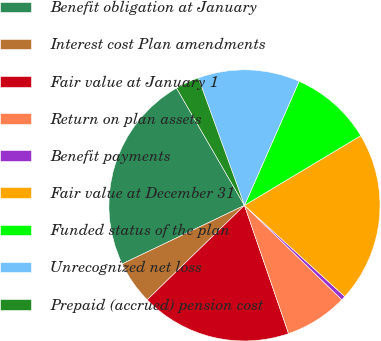Convert chart. <chart><loc_0><loc_0><loc_500><loc_500><pie_chart><fcel>Benefit obligation at January<fcel>Interest cost Plan amendments<fcel>Fair value at January 1<fcel>Return on plan assets<fcel>Benefit payments<fcel>Fair value at December 31<fcel>Funded status of the plan<fcel>Unrecognized net loss<fcel>Prepaid (accrued) pension cost<nl><fcel>23.75%<fcel>5.16%<fcel>18.01%<fcel>7.48%<fcel>0.51%<fcel>20.33%<fcel>9.8%<fcel>12.13%<fcel>2.83%<nl></chart> 